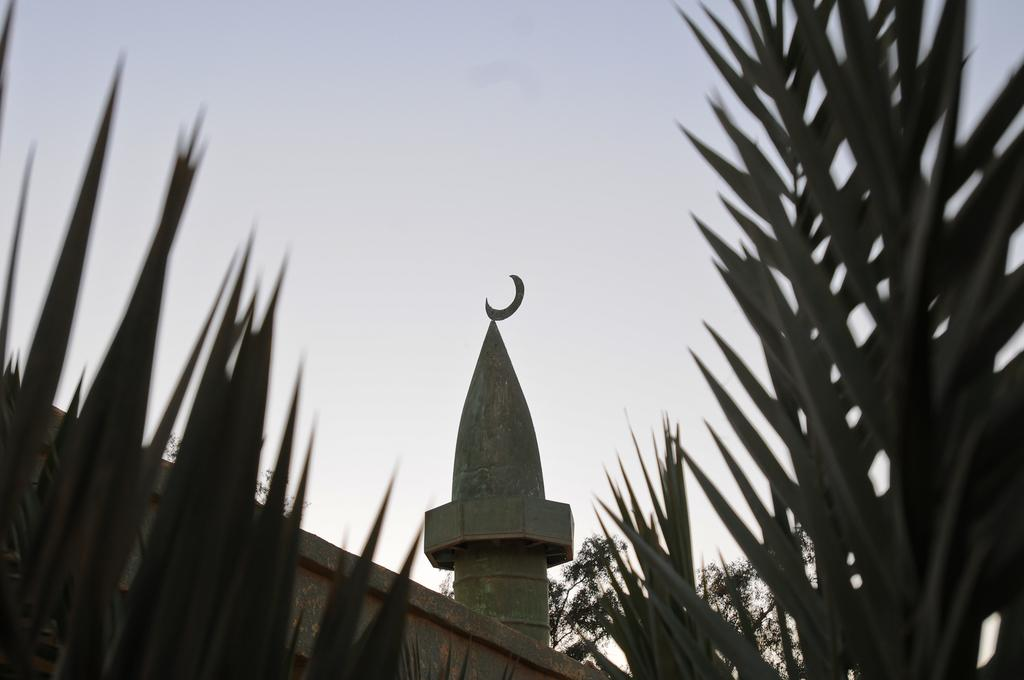What type of vegetation can be seen in the image? There are trees in the image. What type of structure is visible in the image? There is a wall and a tower in the image. What is visible in the background of the image? A: The sky is visible in the background of the image. What type of crown is worn by the bridge in the image? There is no bridge present in the image, and therefore no crown can be associated with it. What does the caption say about the wall in the image? There is no caption present in the image, so we cannot determine what it might say about the wall. 